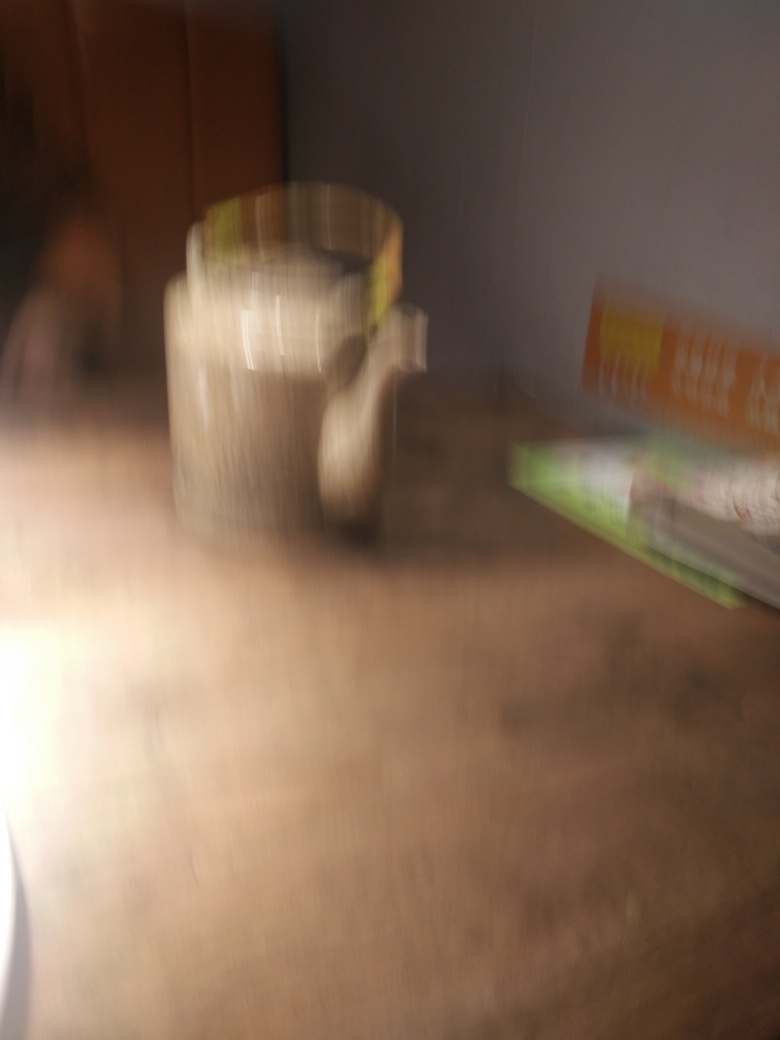Is the subject of the image blurry?
A. No
B. Yes
Answer with the option's letter from the given choices directly.
 B. 